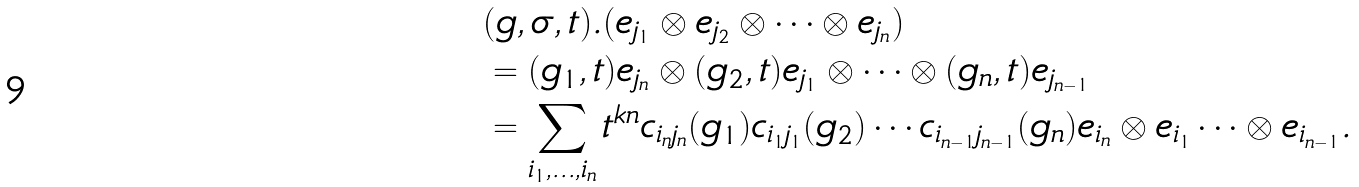Convert formula to latex. <formula><loc_0><loc_0><loc_500><loc_500>& ( g , \sigma , t ) . ( e _ { j _ { 1 } } \otimes e _ { j _ { 2 } } \otimes \cdots \otimes e _ { j _ { n } } ) \\ & = ( g _ { 1 } , t ) e _ { j _ { n } } \otimes ( g _ { 2 } , t ) e _ { j _ { 1 } } \otimes \cdots \otimes ( g _ { n } , t ) e _ { j _ { n - 1 } } \\ & = \sum _ { i _ { 1 } , \dots , i _ { n } } t ^ { k n } c _ { i _ { n } j _ { n } } ( g _ { 1 } ) c _ { i _ { 1 } j _ { 1 } } ( g _ { 2 } ) \cdots c _ { i _ { n - 1 } j _ { n - 1 } } ( g _ { n } ) e _ { i _ { n } } \otimes e _ { i _ { 1 } } \cdots \otimes e _ { i _ { n - 1 } } .</formula> 